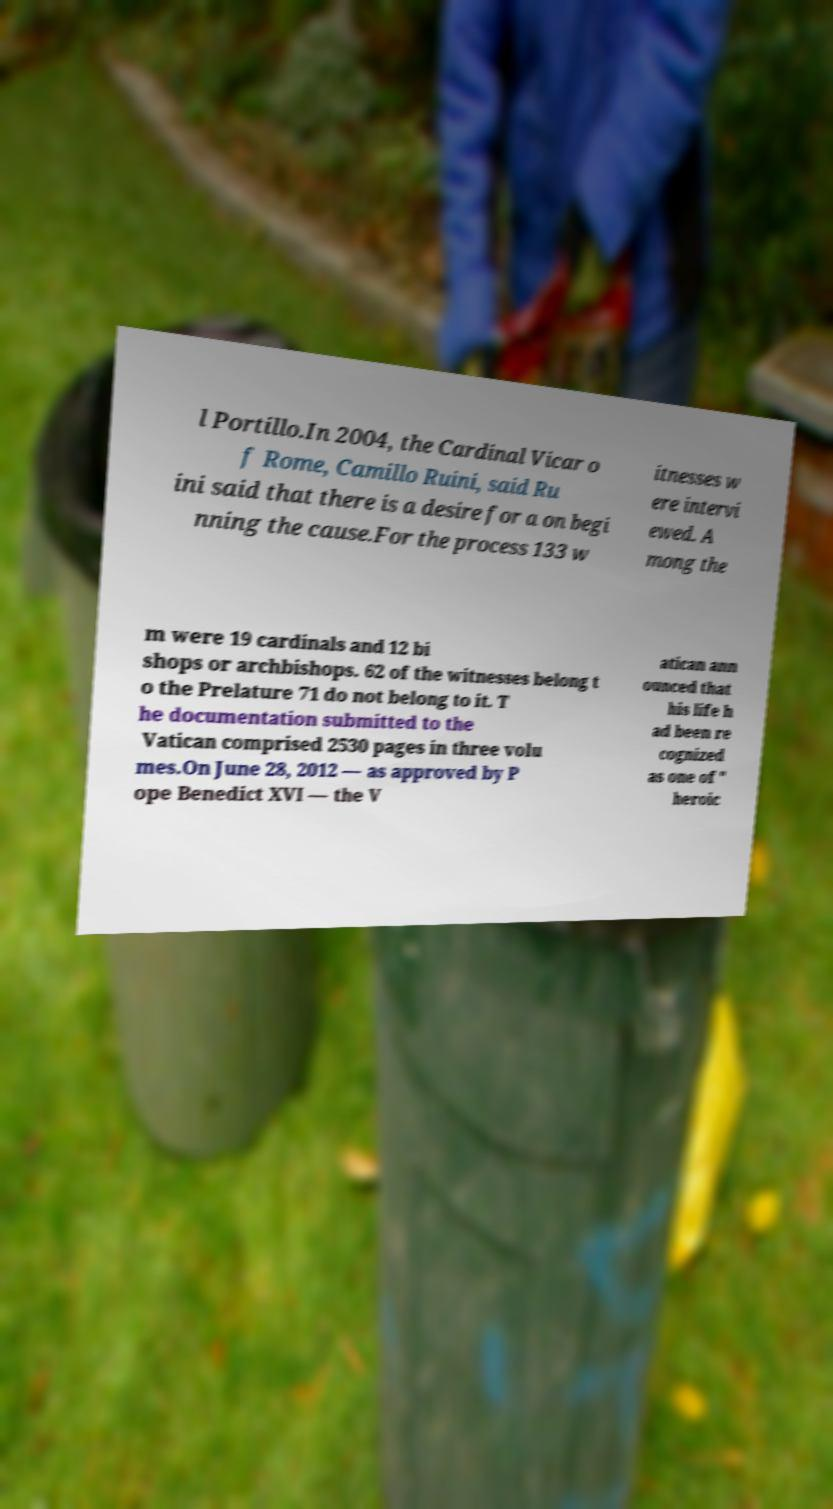For documentation purposes, I need the text within this image transcribed. Could you provide that? l Portillo.In 2004, the Cardinal Vicar o f Rome, Camillo Ruini, said Ru ini said that there is a desire for a on begi nning the cause.For the process 133 w itnesses w ere intervi ewed. A mong the m were 19 cardinals and 12 bi shops or archbishops. 62 of the witnesses belong t o the Prelature 71 do not belong to it. T he documentation submitted to the Vatican comprised 2530 pages in three volu mes.On June 28, 2012 — as approved by P ope Benedict XVI — the V atican ann ounced that his life h ad been re cognized as one of " heroic 